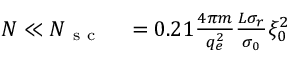Convert formula to latex. <formula><loc_0><loc_0><loc_500><loc_500>\begin{array} { r l } { N \ll N _ { s c } } & = 0 . 2 1 \frac { 4 \pi m } { q _ { e } ^ { 2 } } \frac { L \sigma _ { r } } { \sigma _ { 0 } } \xi _ { 0 } ^ { 2 } } \end{array}</formula> 